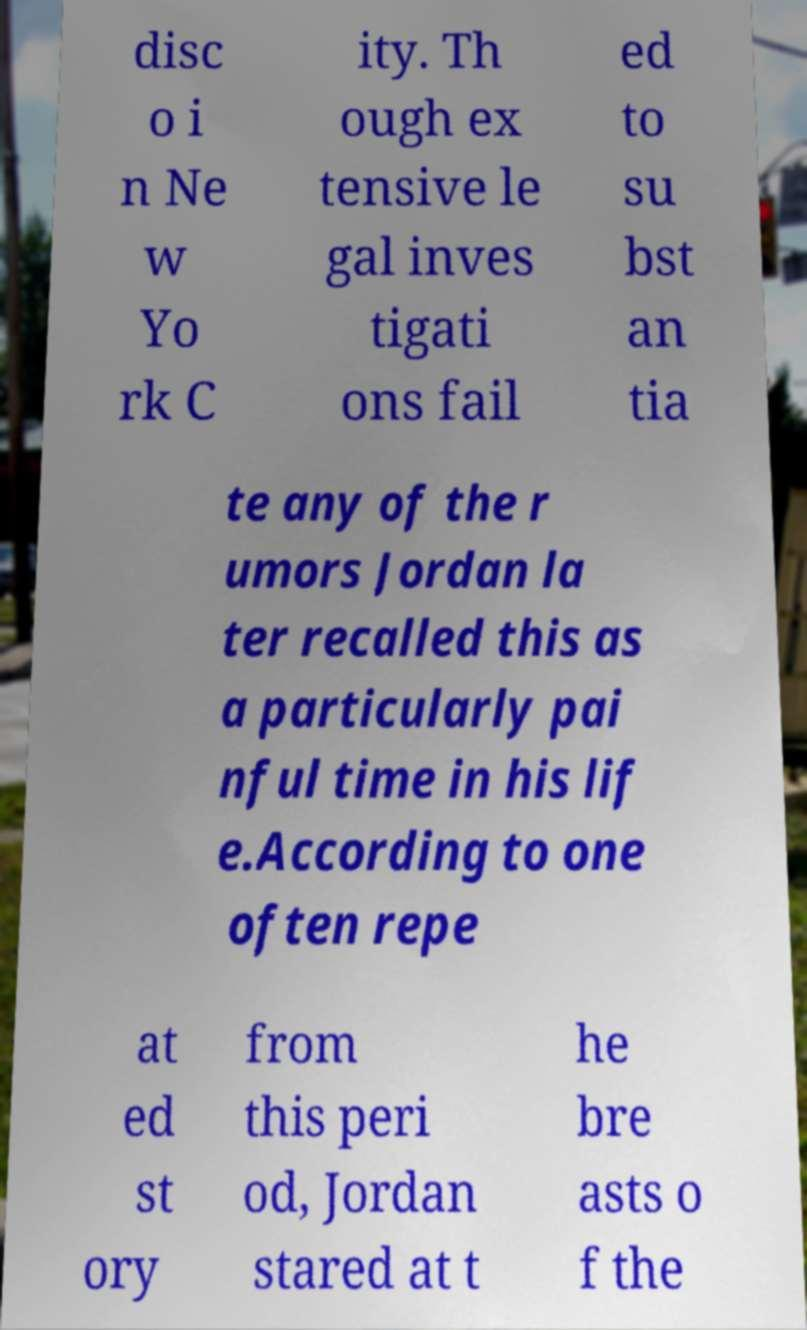What messages or text are displayed in this image? I need them in a readable, typed format. disc o i n Ne w Yo rk C ity. Th ough ex tensive le gal inves tigati ons fail ed to su bst an tia te any of the r umors Jordan la ter recalled this as a particularly pai nful time in his lif e.According to one often repe at ed st ory from this peri od, Jordan stared at t he bre asts o f the 